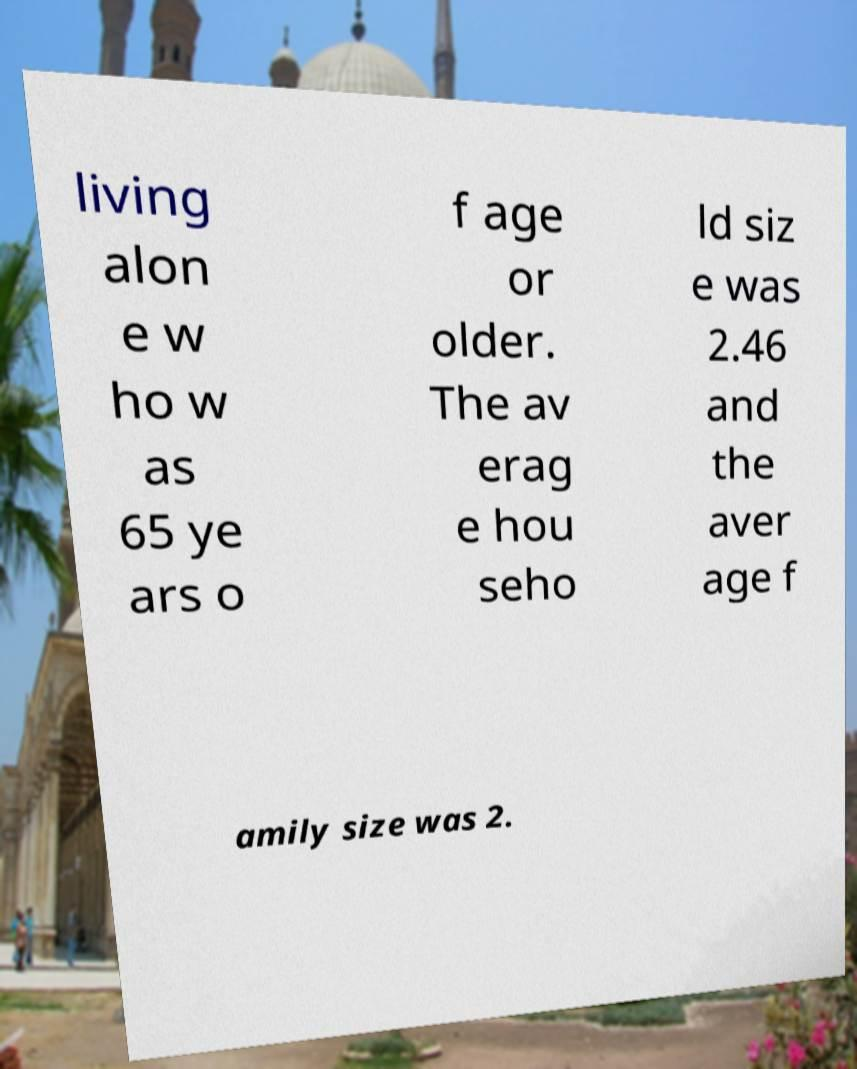Please identify and transcribe the text found in this image. living alon e w ho w as 65 ye ars o f age or older. The av erag e hou seho ld siz e was 2.46 and the aver age f amily size was 2. 